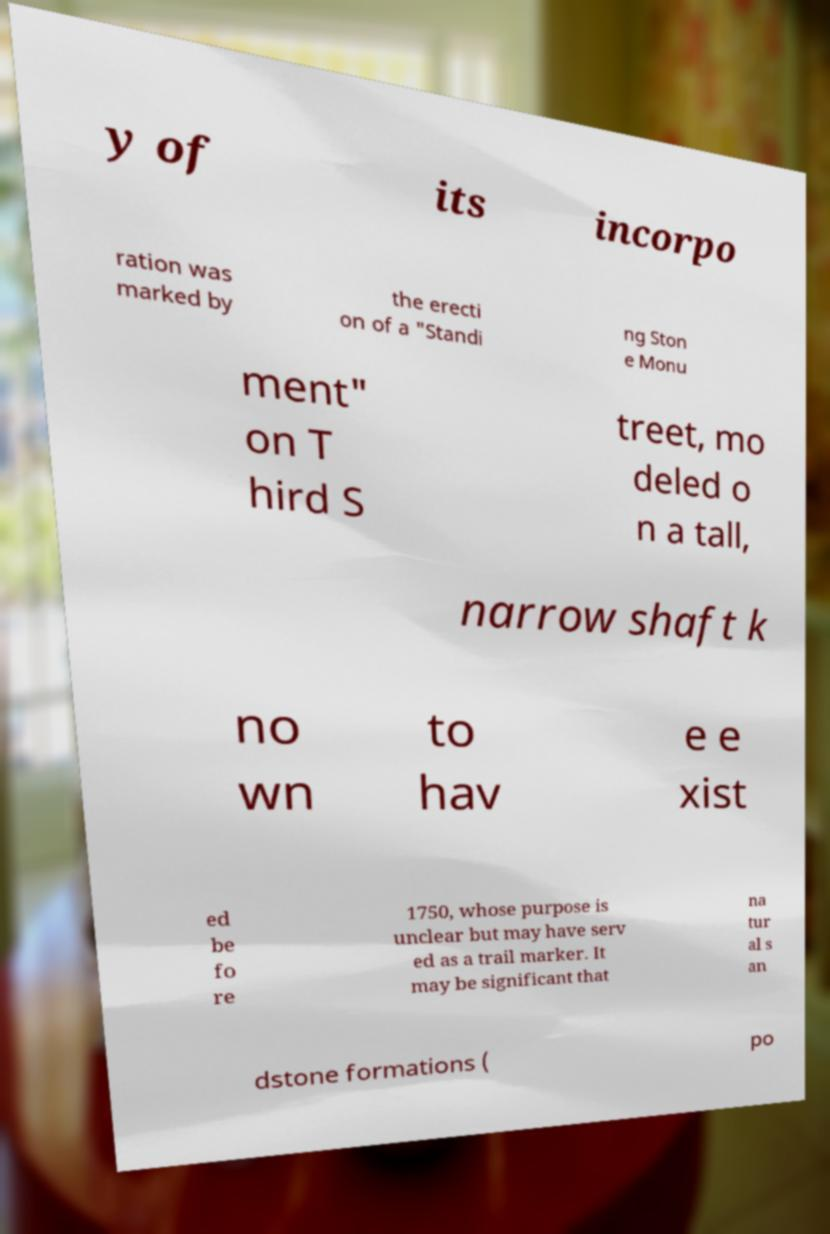Can you read and provide the text displayed in the image?This photo seems to have some interesting text. Can you extract and type it out for me? y of its incorpo ration was marked by the erecti on of a "Standi ng Ston e Monu ment" on T hird S treet, mo deled o n a tall, narrow shaft k no wn to hav e e xist ed be fo re 1750, whose purpose is unclear but may have serv ed as a trail marker. It may be significant that na tur al s an dstone formations ( po 